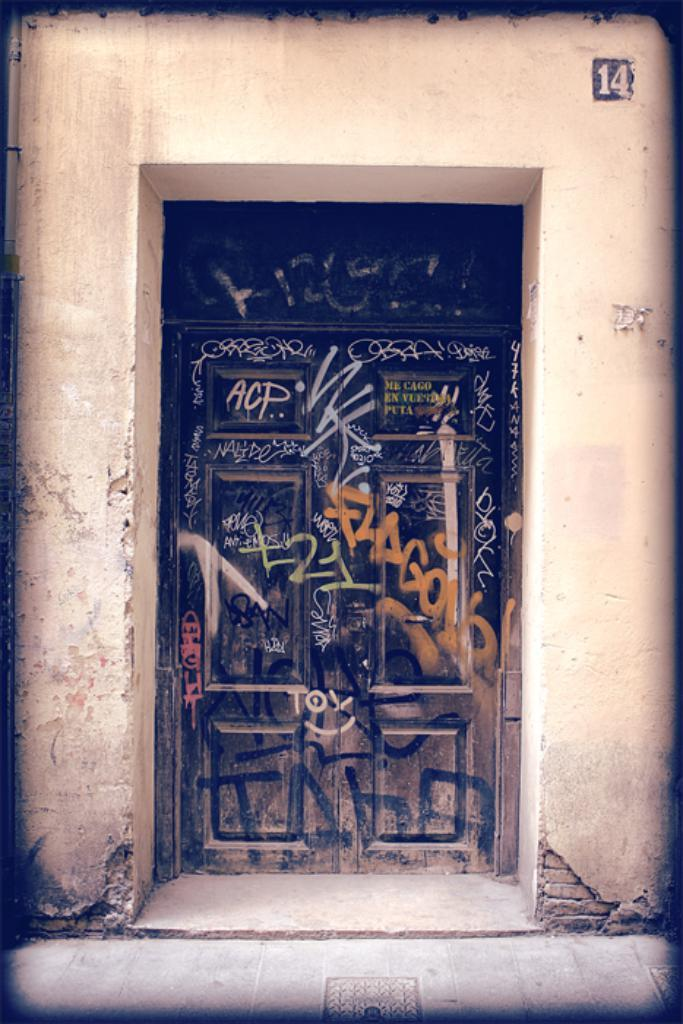What is the main structure visible in the image? There is a wall in the image. What feature is present on the wall? The wall has a door. What is written or painted on the door? There is text painted on the door. What surface is visible at the bottom of the image? There is a floor visible at the bottom of the image. How many deer can be seen grazing on the wire in the image? There are no deer or wire present in the image. What type of sugar is being used to sweeten the text on the door? There is no sugar mentioned or visible in the image. 